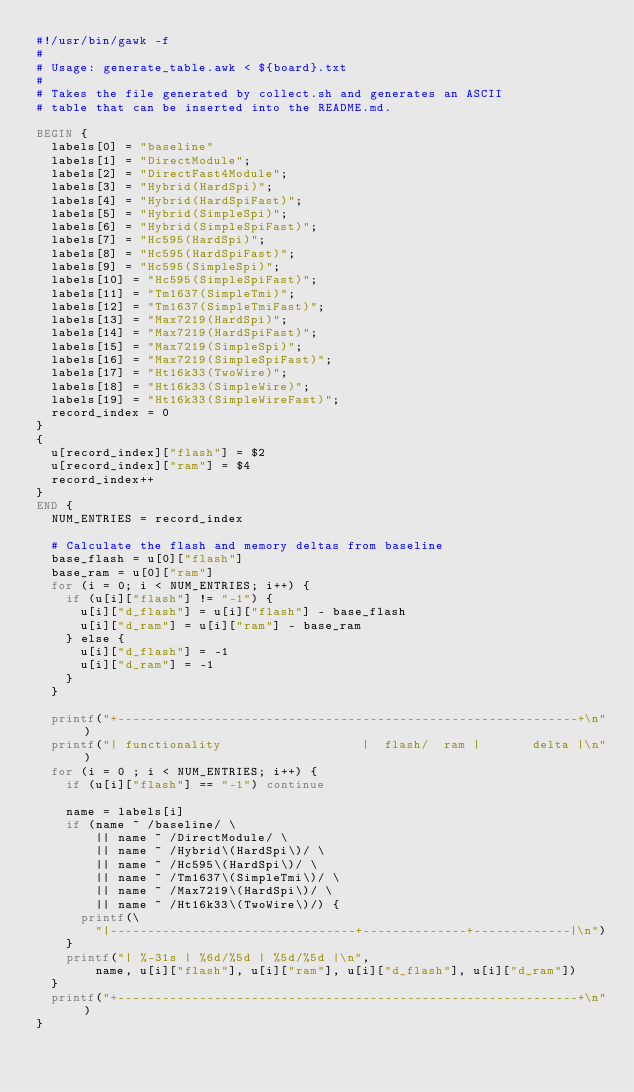Convert code to text. <code><loc_0><loc_0><loc_500><loc_500><_Awk_>#!/usr/bin/gawk -f
#
# Usage: generate_table.awk < ${board}.txt
#
# Takes the file generated by collect.sh and generates an ASCII
# table that can be inserted into the README.md.

BEGIN {
  labels[0] = "baseline"
  labels[1] = "DirectModule";
  labels[2] = "DirectFast4Module";
  labels[3] = "Hybrid(HardSpi)";
  labels[4] = "Hybrid(HardSpiFast)";
  labels[5] = "Hybrid(SimpleSpi)";
  labels[6] = "Hybrid(SimpleSpiFast)";
  labels[7] = "Hc595(HardSpi)";
  labels[8] = "Hc595(HardSpiFast)";
  labels[9] = "Hc595(SimpleSpi)";
  labels[10] = "Hc595(SimpleSpiFast)";
  labels[11] = "Tm1637(SimpleTmi)";
  labels[12] = "Tm1637(SimpleTmiFast)";
  labels[13] = "Max7219(HardSpi)";
  labels[14] = "Max7219(HardSpiFast)";
  labels[15] = "Max7219(SimpleSpi)";
  labels[16] = "Max7219(SimpleSpiFast)";
  labels[17] = "Ht16k33(TwoWire)";
  labels[18] = "Ht16k33(SimpleWire)";
  labels[19] = "Ht16k33(SimpleWireFast)";
  record_index = 0
}
{
  u[record_index]["flash"] = $2
  u[record_index]["ram"] = $4
  record_index++
}
END {
  NUM_ENTRIES = record_index

  # Calculate the flash and memory deltas from baseline
  base_flash = u[0]["flash"]
  base_ram = u[0]["ram"]
  for (i = 0; i < NUM_ENTRIES; i++) {
    if (u[i]["flash"] != "-1") {
      u[i]["d_flash"] = u[i]["flash"] - base_flash
      u[i]["d_ram"] = u[i]["ram"] - base_ram
    } else {
      u[i]["d_flash"] = -1
      u[i]["d_ram"] = -1
    }
  }

  printf("+--------------------------------------------------------------+\n")
  printf("| functionality                   |  flash/  ram |       delta |\n")
  for (i = 0 ; i < NUM_ENTRIES; i++) {
    if (u[i]["flash"] == "-1") continue

    name = labels[i]
    if (name ~ /baseline/ \
        || name ~ /DirectModule/ \
        || name ~ /Hybrid\(HardSpi\)/ \
        || name ~ /Hc595\(HardSpi\)/ \
        || name ~ /Tm1637\(SimpleTmi\)/ \
        || name ~ /Max7219\(HardSpi\)/ \
        || name ~ /Ht16k33\(TwoWire\)/) {
      printf(\
        "|---------------------------------+--------------+-------------|\n")
    }
    printf("| %-31s | %6d/%5d | %5d/%5d |\n",
        name, u[i]["flash"], u[i]["ram"], u[i]["d_flash"], u[i]["d_ram"])
  }
  printf("+--------------------------------------------------------------+\n")
}
</code> 